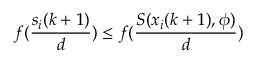<formula> <loc_0><loc_0><loc_500><loc_500>f ( \frac { s _ { i } ( k + 1 ) } { d } ) \leq f ( \frac { S ( x _ { i } ( k + 1 ) , \phi ) } { d } )</formula> 